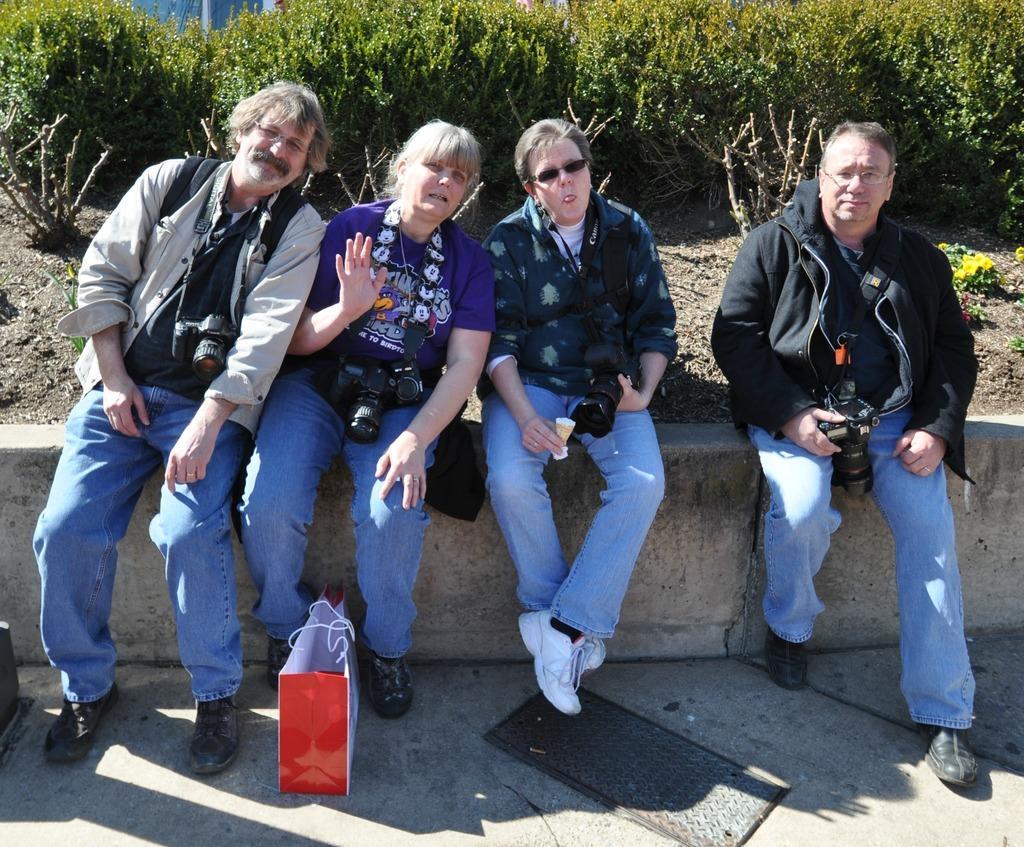Can you describe this image briefly? In this image, we can see some people sitting on the wall and there is a bag on the ground, we can see some green plants. 